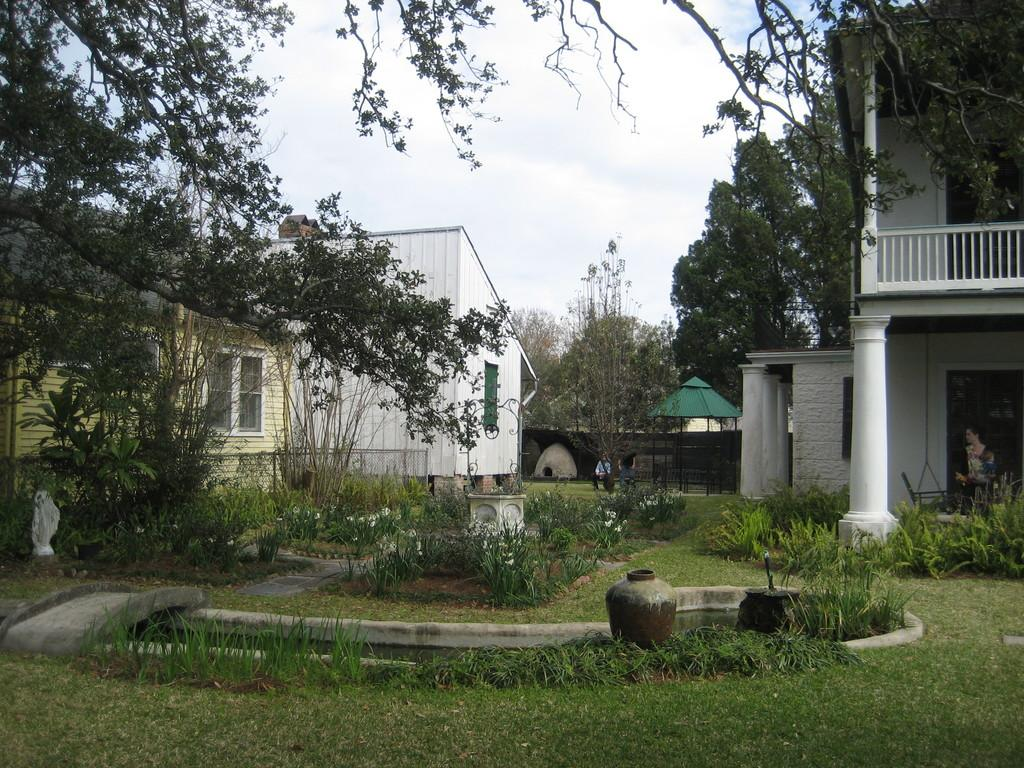What type of vegetation can be seen in the image? There are plants, trees, and grassy land visible in the image. What is the pot used for in the image? The pot is likely used for holding or growing plants. What type of structures are present in the image? There are buildings visible in the image. What can be seen in the background of the image? The sky is visible in the background of the image. Where is the tent located in the image? There is no tent present in the image. What type of house is visible in the image? There is no house present in the image. 